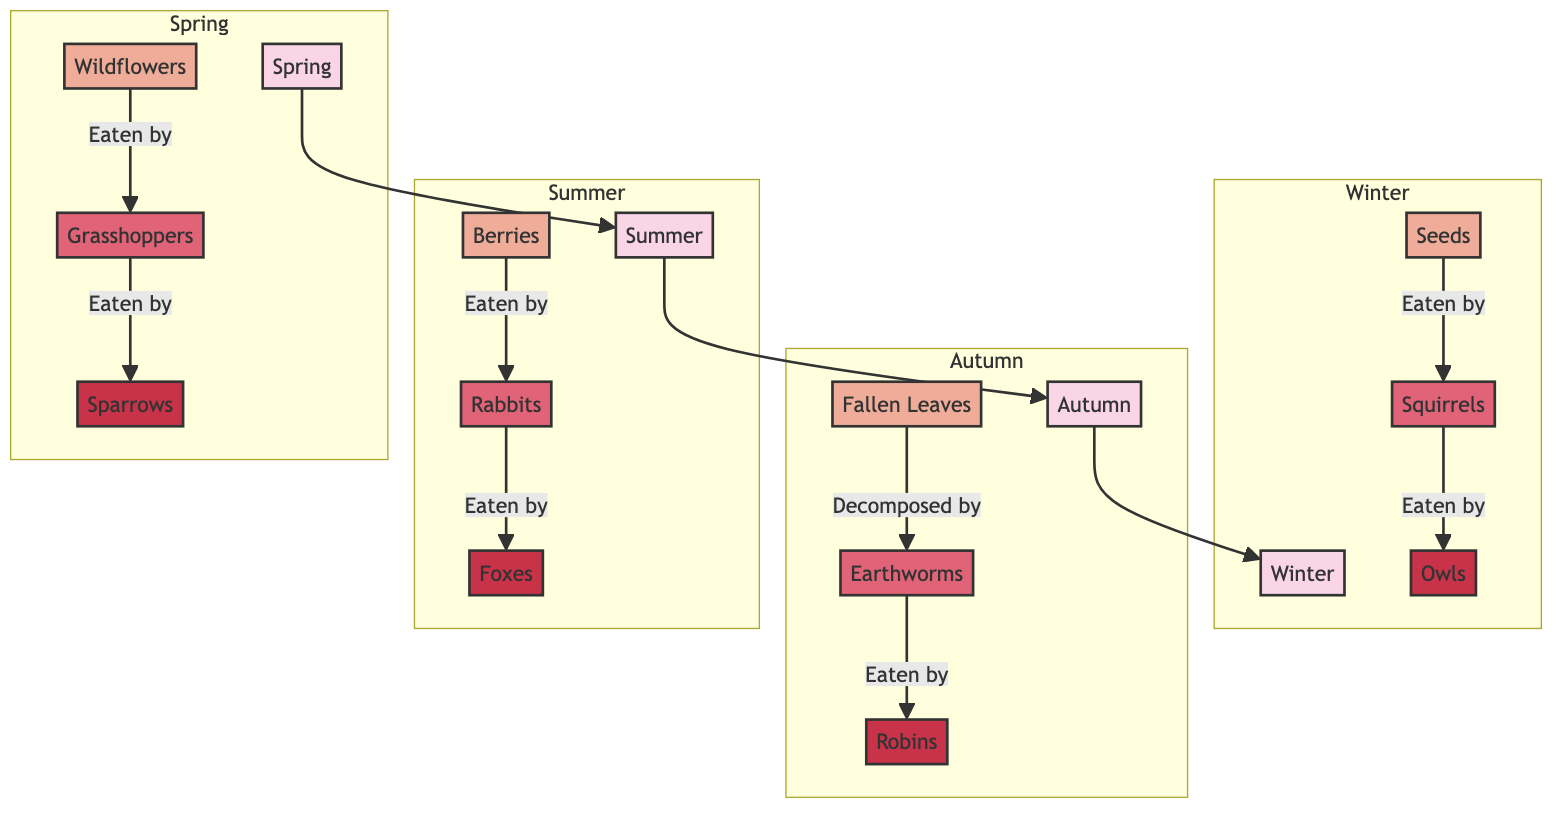What is the main producer in Spring? The main producer in Spring is depicted in the node labeled "Wildflowers". This is identified by looking for the first layer in the Spring subgraph, which lists "Wildflowers" as the only producer.
Answer: Wildflowers Which primary consumer is associated with Autumn? The primary consumer in Autumn is represented by the node "Earthworms". This can be determined by examining the Autumn subgraph and identifying the first consumer node, which is specifically labeled as having that role.
Answer: Earthworms How many secondary consumers are there across the seasons? In the diagram, there is one secondary consumer in each seasonal subgraph, totaling four: Sparrows (Spring), Foxes (Summer), Robins (Autumn), and Owls (Winter). Adding these together gives a total of 4 secondary consumers.
Answer: 4 What do Rabbits eat in the Summer? In the Summer subgraph, "Rabbits" eat "Berries". This relationship can be traced directly from the edge that connects the node for Berries to the node for Rabbits, indicating that Rabbits are the primary consumers of Berries.
Answer: Berries Which season has the producer labeled as "Seeds"? The producer labeled as "Seeds" is in the Winter subgraph. To find this, one can look for the producers listed across each seasonal subgraph and note that "Seeds" is uniquely placed in the Winter section.
Answer: Winter What is the food chain progression from Winter to Spring? The food chain progression from Winter to Spring can be analyzed by looking at the directed connections between the seasonal subgraphs. Starting from "Seeds" in Winter, we follow the pathway into Spring, which connects through the seasonal transition to "Wildflowers". The chain is considered as Seeds → Squirrels → Owls (Winter), followed by Wildflowers → Grasshoppers → Sparrows (Spring).
Answer: Seeds → Squirrels → Owls → Wildflowers → Grasshoppers → Sparrows What role do Foxes play in the Summer food chain? "Foxes" are categorized as secondary consumers in the Summer food chain. This is determined by examining the Summer subgraph and seeing that Foxes are connected to the primary consumer "Rabbits", signifying their role in the food chain hierarchy.
Answer: Secondary consumer 